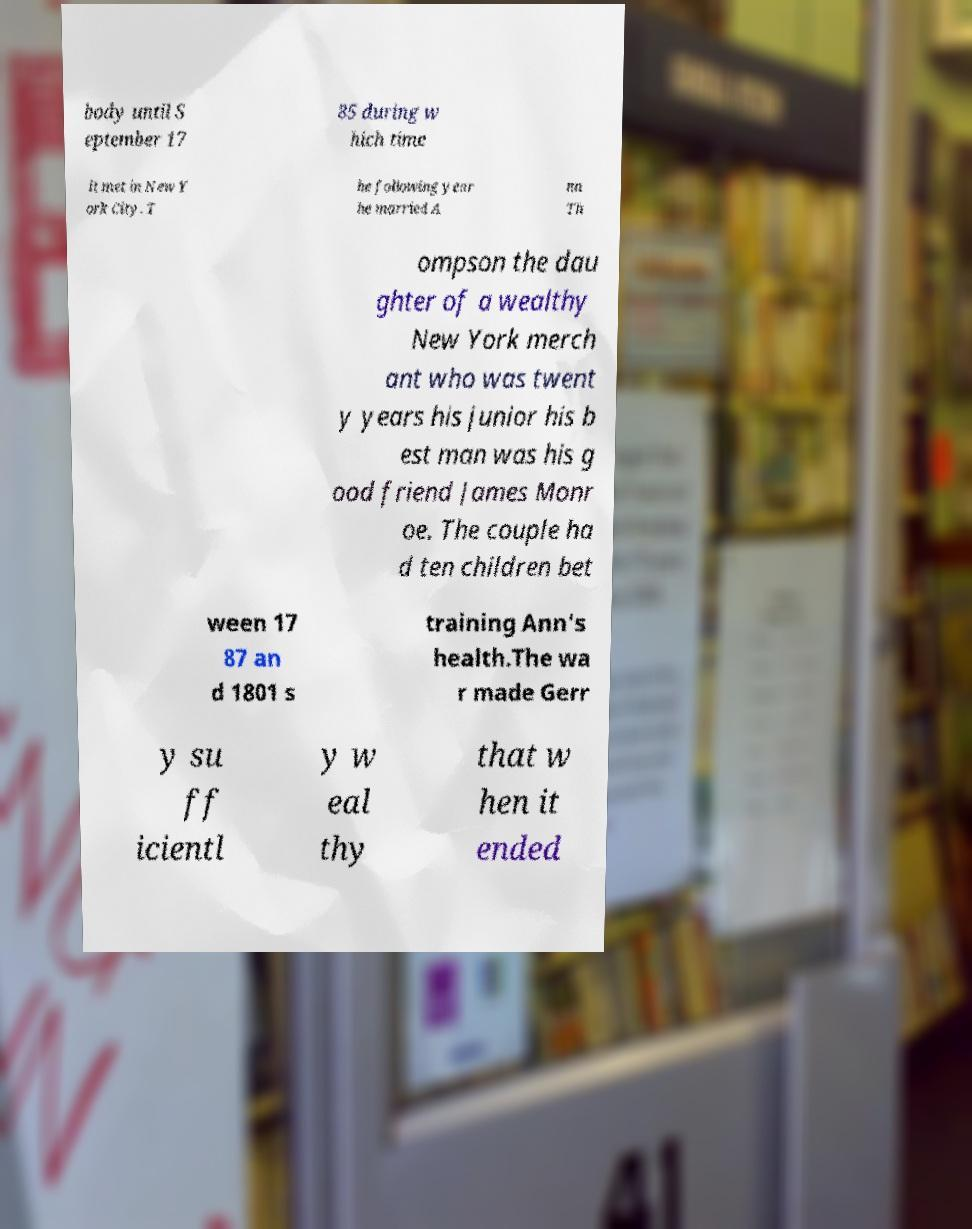Could you extract and type out the text from this image? body until S eptember 17 85 during w hich time it met in New Y ork City. T he following year he married A nn Th ompson the dau ghter of a wealthy New York merch ant who was twent y years his junior his b est man was his g ood friend James Monr oe. The couple ha d ten children bet ween 17 87 an d 1801 s training Ann's health.The wa r made Gerr y su ff icientl y w eal thy that w hen it ended 